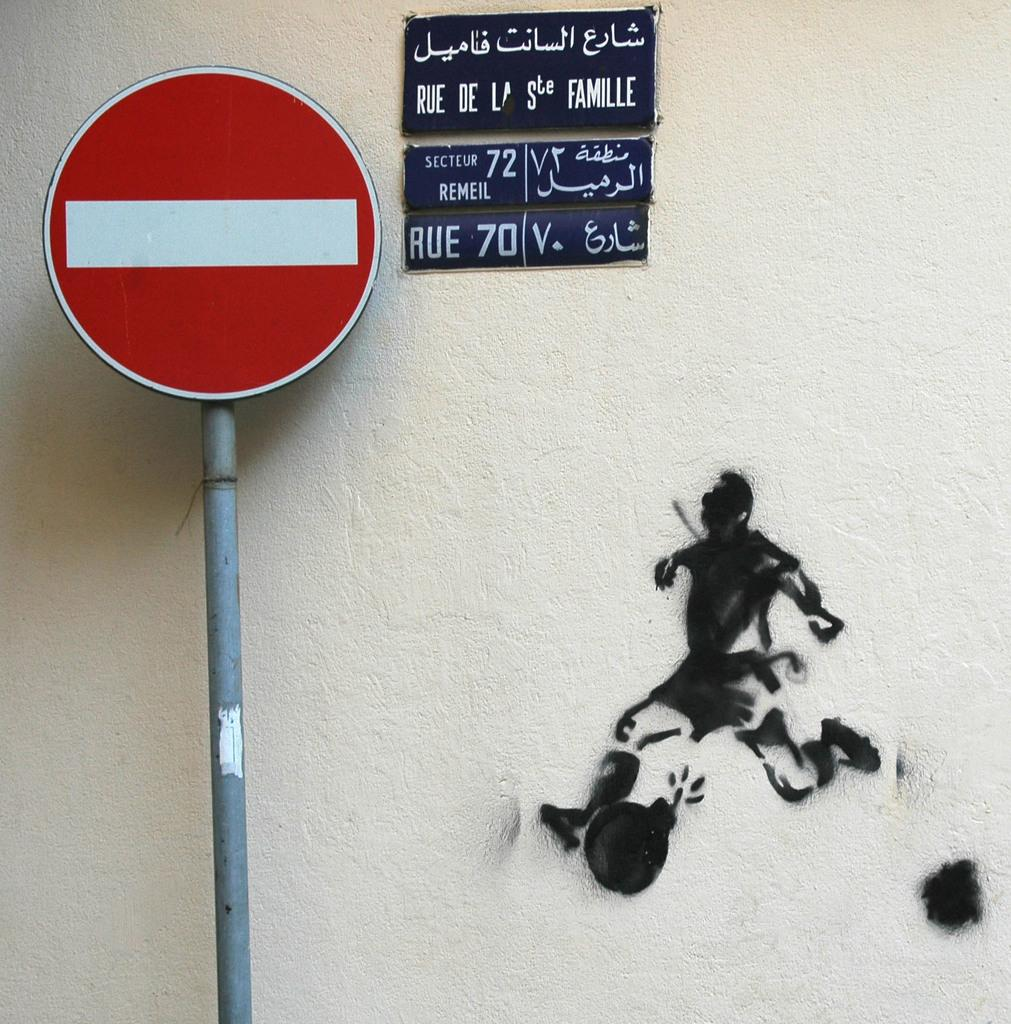Provide a one-sentence caption for the provided image. a do not enter sign with a smaller sign in a foreign language at the right of it and a picture of a man running towards the sign. 